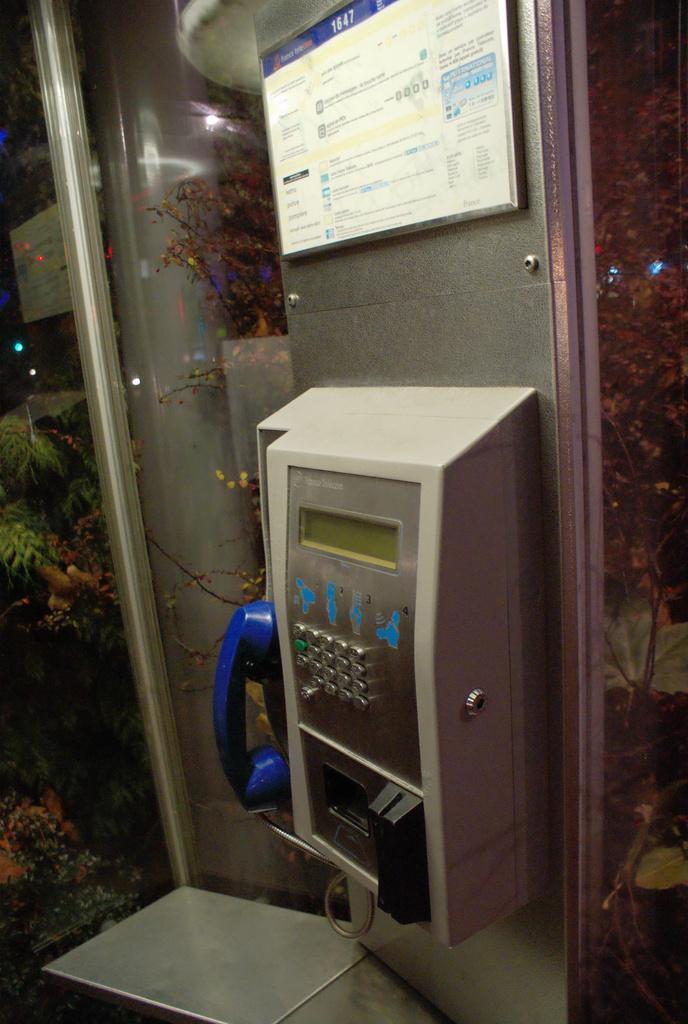In one or two sentences, can you explain what this image depicts? In front of the picture, we see a telephone. At the top, we see a board or a poster in white color with some text written. On the left side, we see the trees and a board in white color with some text written. This picture might be clicked in the telephone booth. On the right side, we see the trees. 